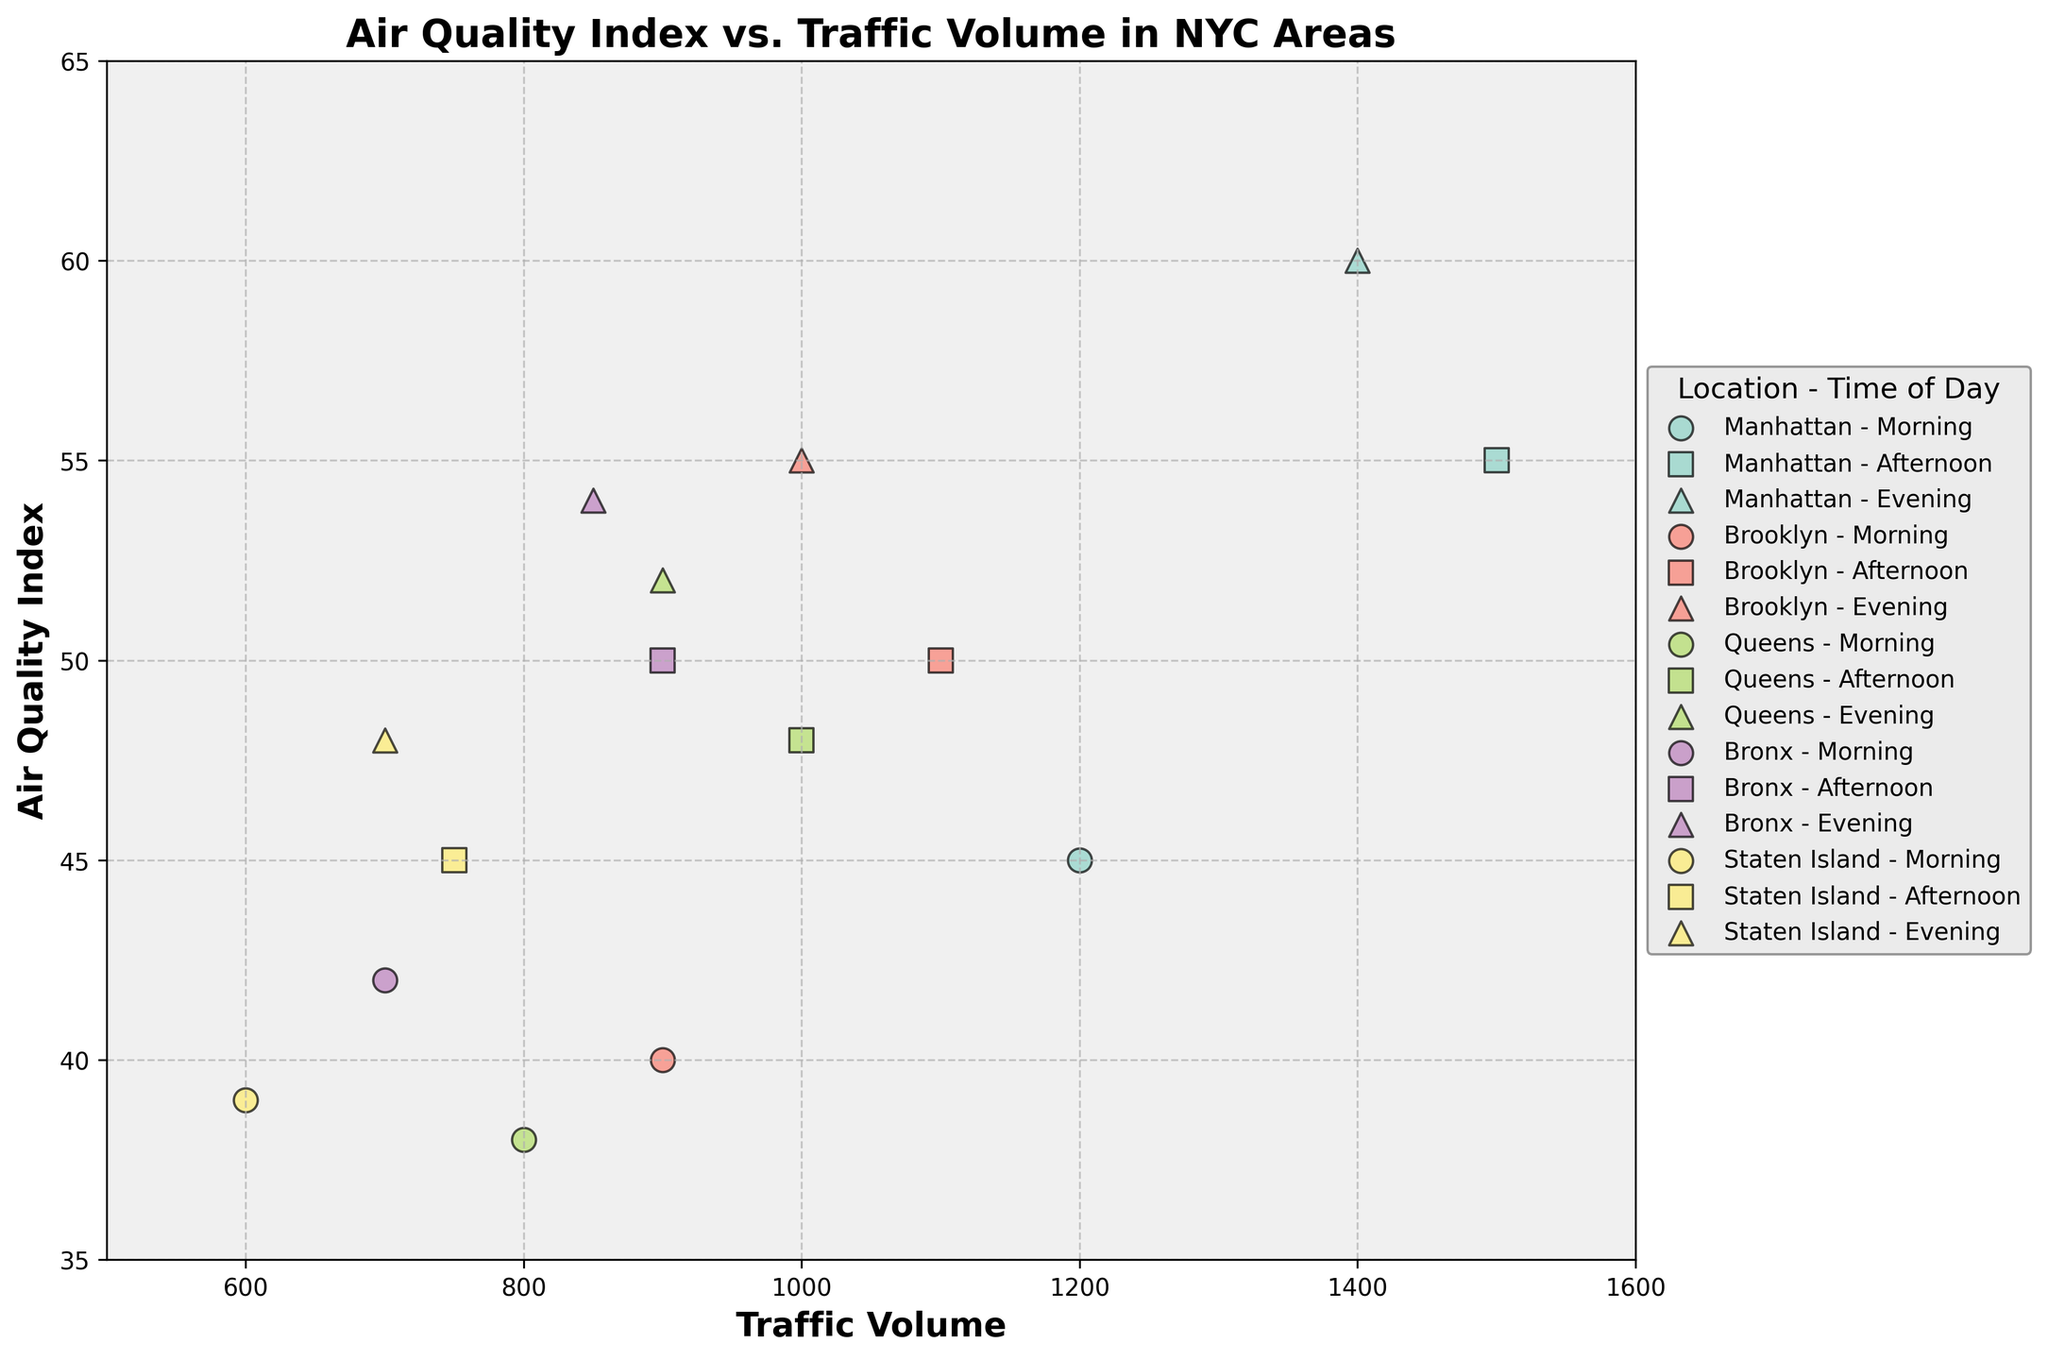How many different areas are represented in the plot? The figure plot includes data points from five different locations in NYC, represented by distinct colors. To determine this, observe the distinct groups labeled in the legend.
Answer: Five What is the traffic volume range that the plot covers? The x-axis of the plot is labeled 'Traffic Volume'. Upon examining the plot, it shows data points ranging from 600 to 1500 in the traffic volume.
Answer: 600 to 1500 Which location has the highest evening traffic volume and what is its corresponding AQI? By cross-referencing the evening time data points in the legend and the scatter points, Manhattan shows the highest evening traffic volume at 1400, with an AQI of 60.
Answer: Manhattan, 60 What is the average AQI for all times of day in Brooklyn? To find this, look at Brooklyn's AQI values for Morning (40), Afternoon (50), and Evening (55). Calculating the average results in (40 + 50 + 55) / 3 = 48.33.
Answer: 48.33 Compare the average AQI between Manhattan and Staten Island. Which has a higher average and by how much? First, calculate the average AQI for Manhattan: (45 + 55 + 60) / 3 = 53.33. Then for Staten Island: (39 + 45 + 48) / 3 = 44. Look at the difference: 53.33 - 44 = 9.33. Manhattan has a higher average AQI by 9.33.
Answer: Manhattan, 9.33 Is there a positive correlation between traffic volume and AQI in any location? If so, which one? By examining the scatter trends for different locations, notable trends suggest that as traffic volume increases, AQI also tends to increase. This trend is visible particularly in Manhattan and Brooklyn.
Answer: Manhattan and Brooklyn Which time of day shows a generally higher AQI across all locations? Reviewing the scatter points for morning, afternoon, and evening within each location, the evening time generally has higher AQI values across Manhattan, Brooklyn, Queens, Bronx, and Staten Island.
Answer: Evening What's the range of AQI values for Queens throughout the day? Look at Queens data points: Morning (38), Afternoon (48), and Evening (52). The range calculation is 52 - 38 = 14.
Answer: 14 Which location had the lowest traffic volume in the Morning and what was the AQI? By identifying the morning data points and finding the minimum traffic volume, Staten Island had the lowest traffic at 600 with an AQI of 39.
Answer: Staten Island, 39 